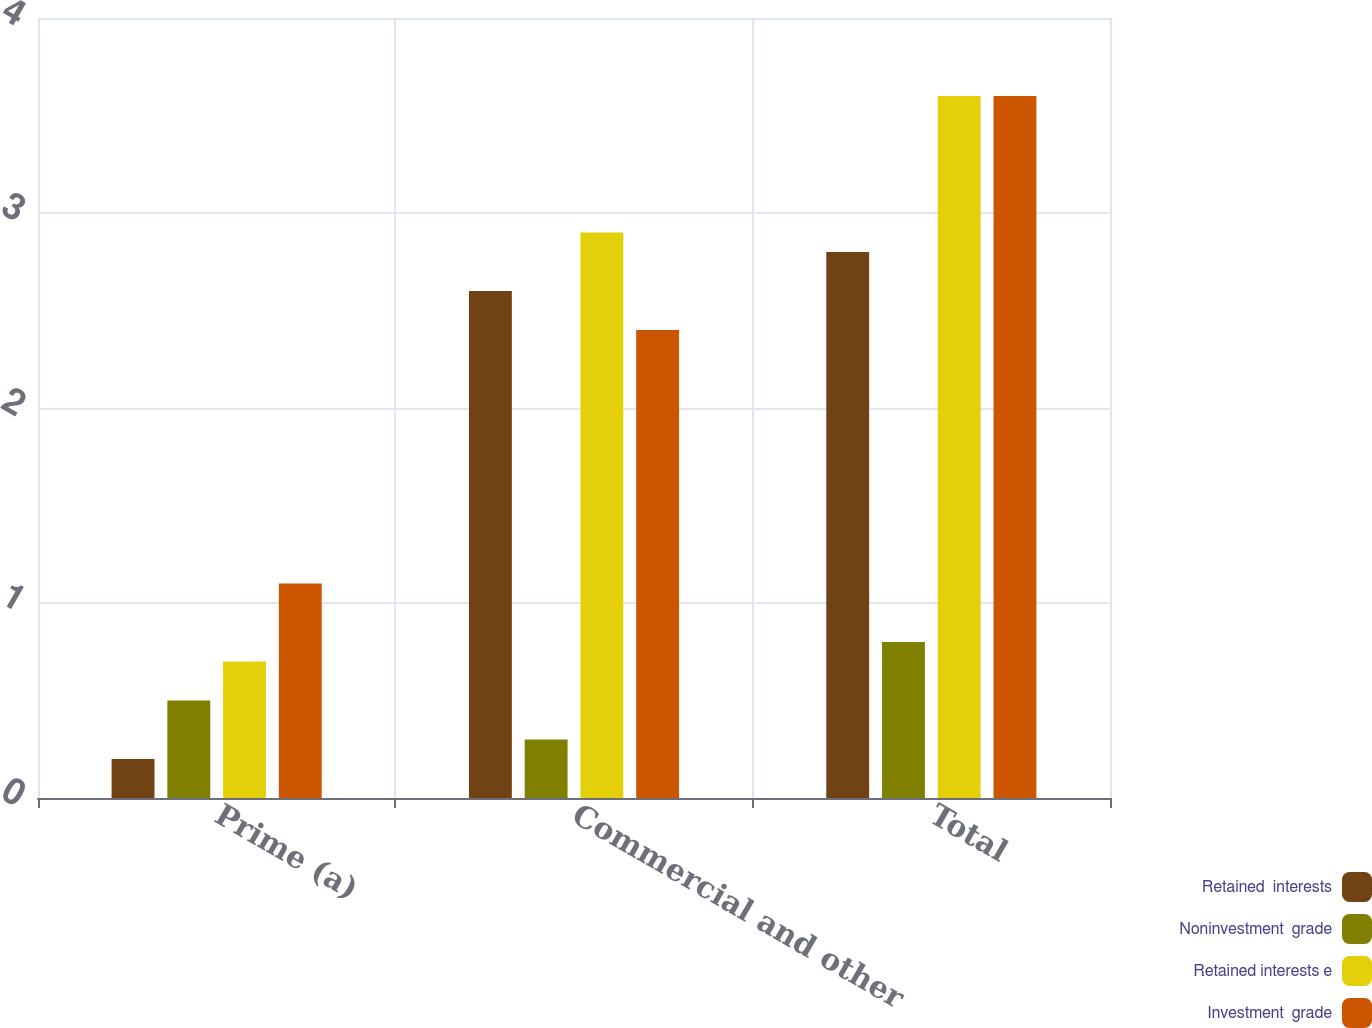Convert chart. <chart><loc_0><loc_0><loc_500><loc_500><stacked_bar_chart><ecel><fcel>Prime (a)<fcel>Commercial and other<fcel>Total<nl><fcel>Retained  interests<fcel>0.2<fcel>2.6<fcel>2.8<nl><fcel>Noninvestment  grade<fcel>0.5<fcel>0.3<fcel>0.8<nl><fcel>Retained interests e<fcel>0.7<fcel>2.9<fcel>3.6<nl><fcel>Investment  grade<fcel>1.1<fcel>2.4<fcel>3.6<nl></chart> 